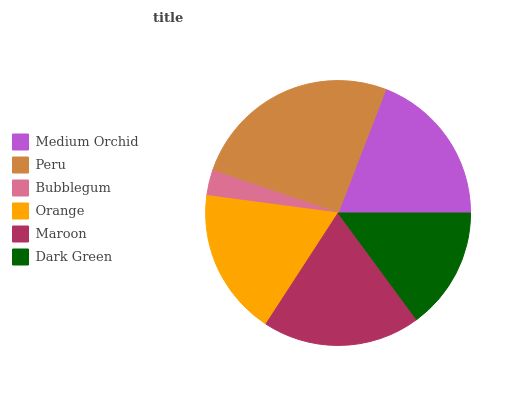Is Bubblegum the minimum?
Answer yes or no. Yes. Is Peru the maximum?
Answer yes or no. Yes. Is Peru the minimum?
Answer yes or no. No. Is Bubblegum the maximum?
Answer yes or no. No. Is Peru greater than Bubblegum?
Answer yes or no. Yes. Is Bubblegum less than Peru?
Answer yes or no. Yes. Is Bubblegum greater than Peru?
Answer yes or no. No. Is Peru less than Bubblegum?
Answer yes or no. No. Is Medium Orchid the high median?
Answer yes or no. Yes. Is Orange the low median?
Answer yes or no. Yes. Is Bubblegum the high median?
Answer yes or no. No. Is Maroon the low median?
Answer yes or no. No. 